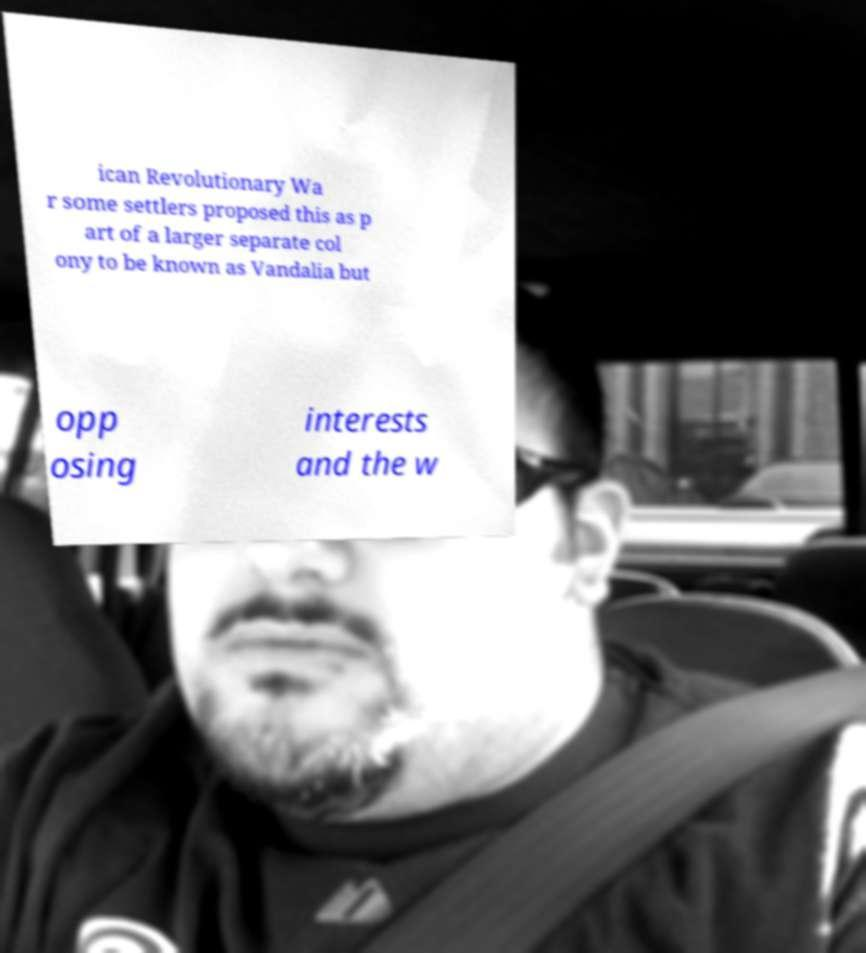Please read and relay the text visible in this image. What does it say? ican Revolutionary Wa r some settlers proposed this as p art of a larger separate col ony to be known as Vandalia but opp osing interests and the w 